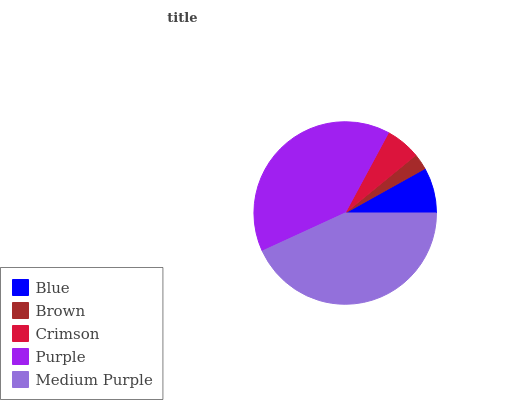Is Brown the minimum?
Answer yes or no. Yes. Is Medium Purple the maximum?
Answer yes or no. Yes. Is Crimson the minimum?
Answer yes or no. No. Is Crimson the maximum?
Answer yes or no. No. Is Crimson greater than Brown?
Answer yes or no. Yes. Is Brown less than Crimson?
Answer yes or no. Yes. Is Brown greater than Crimson?
Answer yes or no. No. Is Crimson less than Brown?
Answer yes or no. No. Is Blue the high median?
Answer yes or no. Yes. Is Blue the low median?
Answer yes or no. Yes. Is Purple the high median?
Answer yes or no. No. Is Brown the low median?
Answer yes or no. No. 